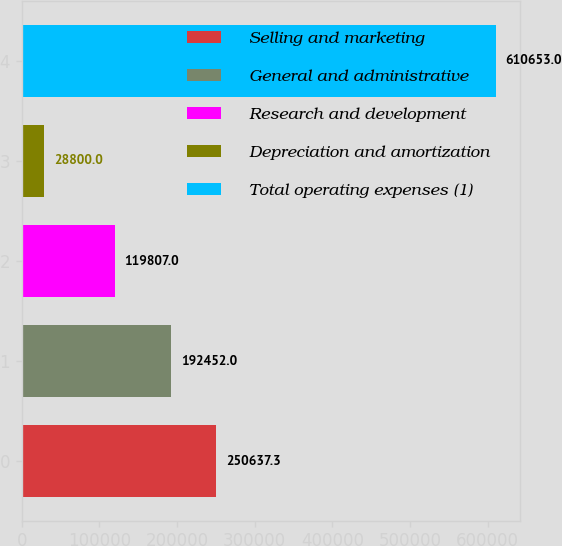Convert chart. <chart><loc_0><loc_0><loc_500><loc_500><bar_chart><fcel>Selling and marketing<fcel>General and administrative<fcel>Research and development<fcel>Depreciation and amortization<fcel>Total operating expenses (1)<nl><fcel>250637<fcel>192452<fcel>119807<fcel>28800<fcel>610653<nl></chart> 